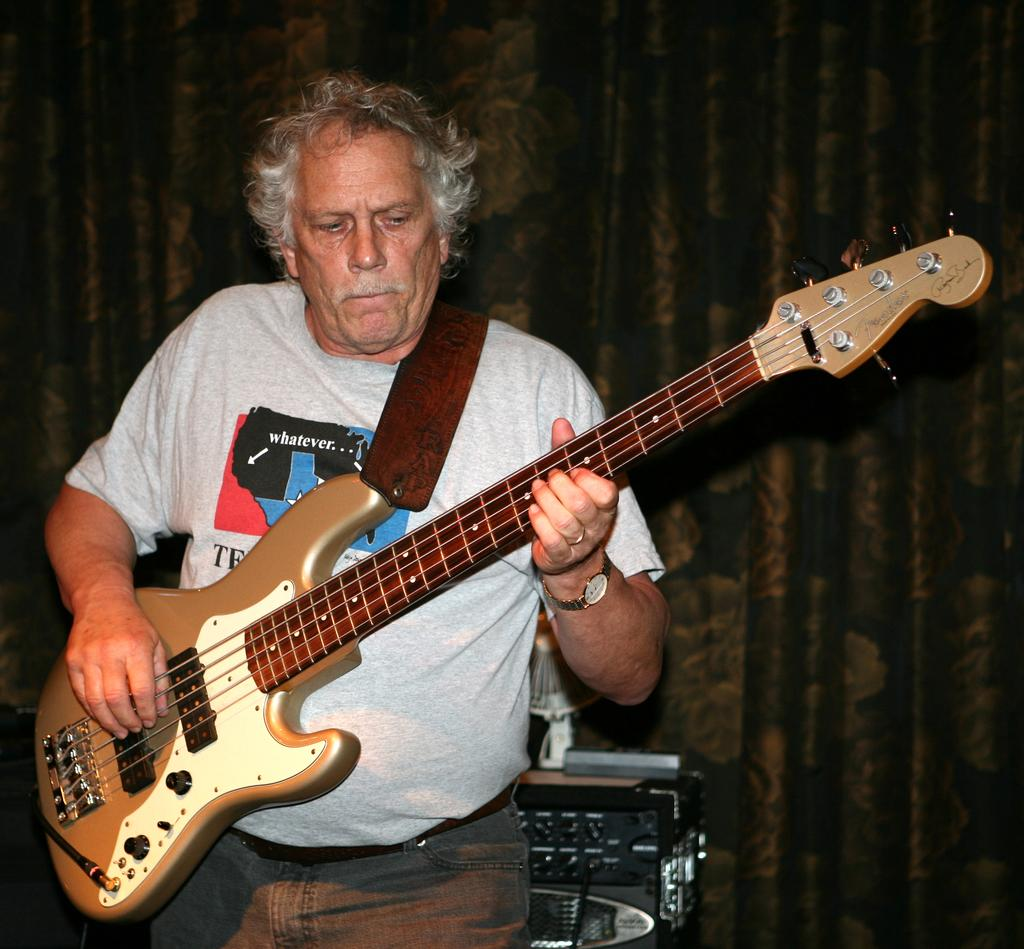What is the person in the image doing? The person is playing a guitar. What is the person wearing in the image? The person is wearing a grey t-shirt. What can be seen in the background of the image? There are curtains visible in the image. What type of company is the person working for in the image? There is no indication of a company or any work-related context in the image. 